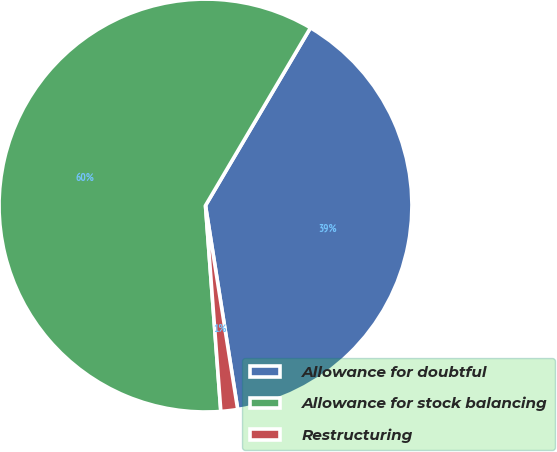<chart> <loc_0><loc_0><loc_500><loc_500><pie_chart><fcel>Allowance for doubtful<fcel>Allowance for stock balancing<fcel>Restructuring<nl><fcel>39.01%<fcel>59.67%<fcel>1.31%<nl></chart> 